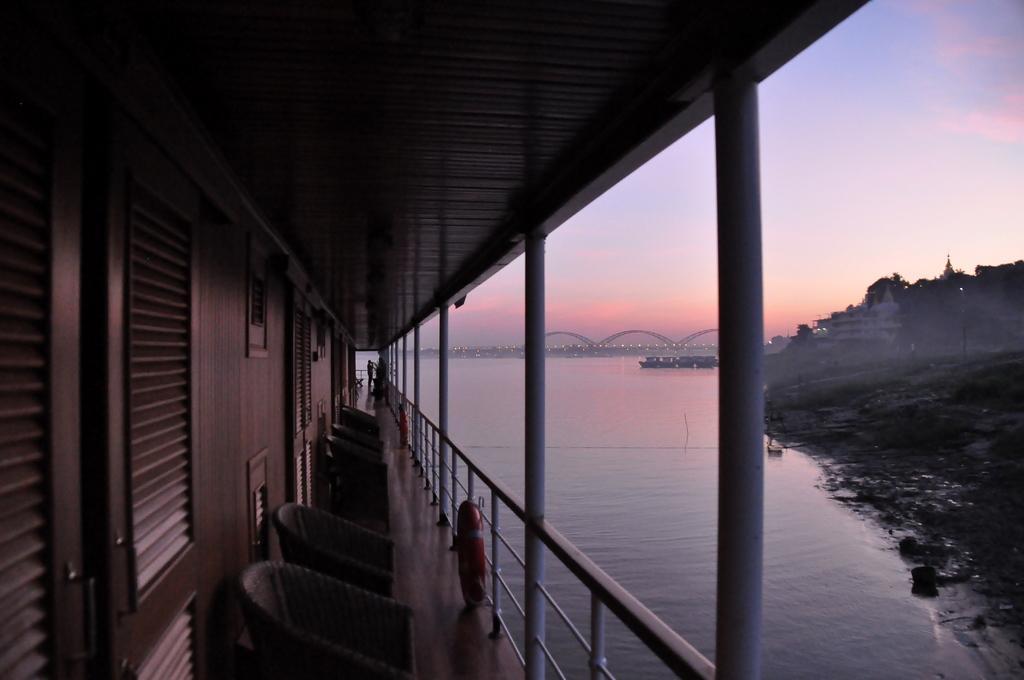Describe this image in one or two sentences. In this image, there is an outside view. There is a boat on the left side of the image contains some chairs. There is a river and bridge in the middle of the image. There is a hill on the right side of the image. There is sky in the top right of the image. 